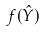Convert formula to latex. <formula><loc_0><loc_0><loc_500><loc_500>f ( \hat { Y } )</formula> 